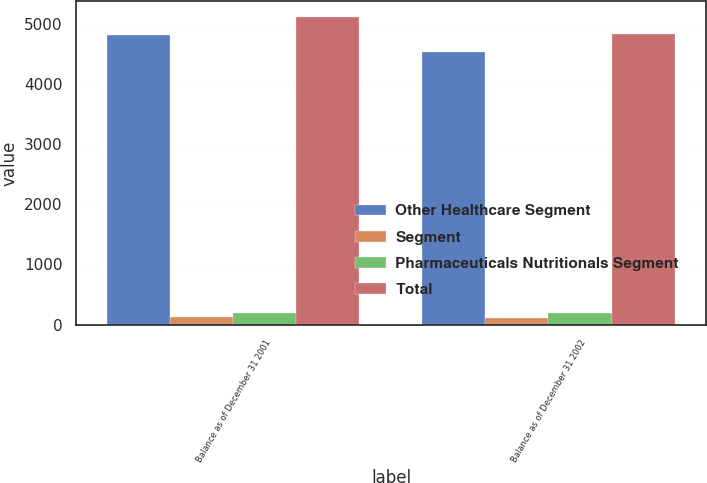<chart> <loc_0><loc_0><loc_500><loc_500><stacked_bar_chart><ecel><fcel>Balance as of December 31 2001<fcel>Balance as of December 31 2002<nl><fcel>Other Healthcare Segment<fcel>4810<fcel>4528<nl><fcel>Segment<fcel>119<fcel>118<nl><fcel>Pharmaceuticals Nutritionals Segment<fcel>190<fcel>190<nl><fcel>Total<fcel>5119<fcel>4836<nl></chart> 